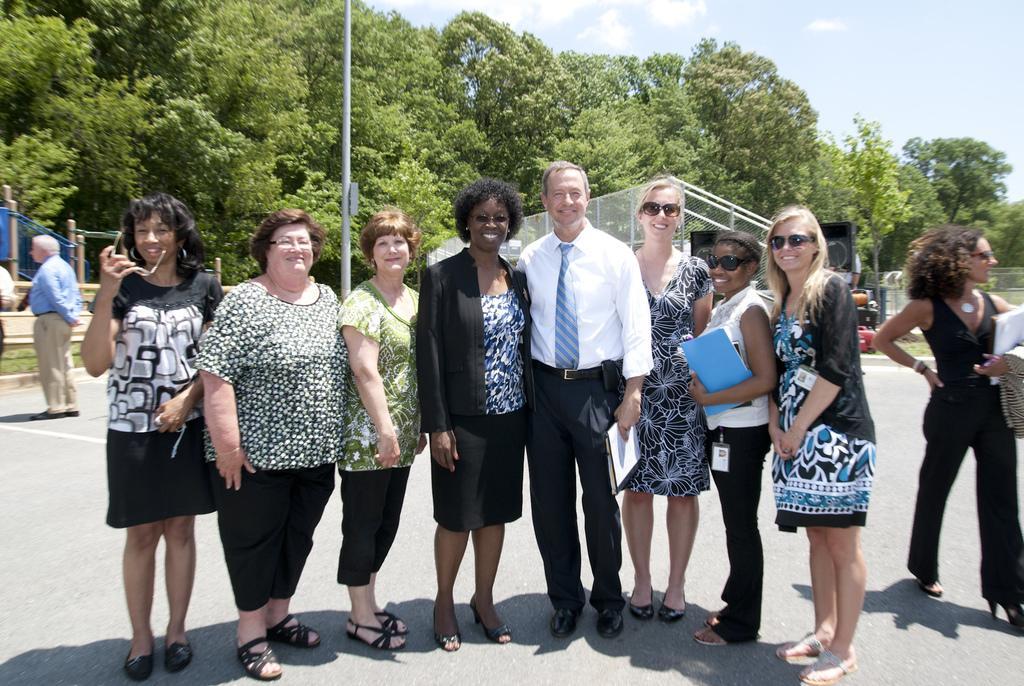Could you give a brief overview of what you see in this image? In the center of the image we can see some persons are standing and smiling and some of them are holding files. In the background of the image we can see the poles, trees, stairs, mesh, bags. At the bottom of the image we can see the road. At the top of the image we can see the clouds are present in the sky. 